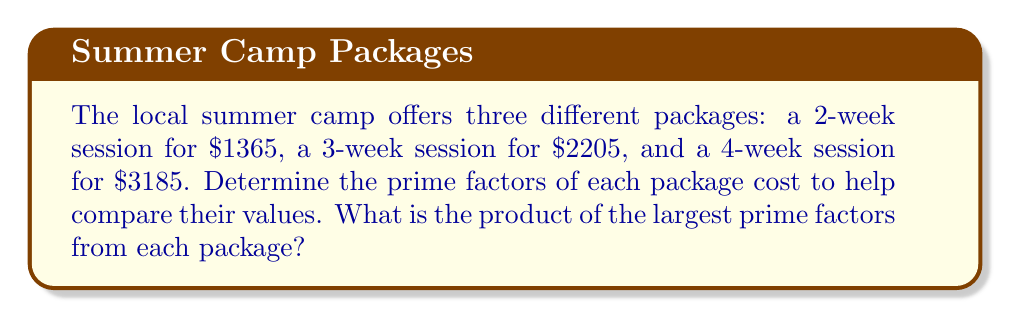Can you solve this math problem? Let's find the prime factors of each package cost:

1. 2-week session: $1365
   $1365 = 3 \times 5 \times 7 \times 13$

2. 3-week session: $2205
   $2205 = 3^2 \times 5 \times 7^2$

3. 4-week session: $3185
   $3185 = 5 \times 637$

Now, we identify the largest prime factor for each package:
1. 2-week session: 13
2. 3-week session: 7
3. 4-week session: 637

To find the product of these largest prime factors:

$13 \times 7 \times 637 = 58,006$

This calculation helps compare the relative "value" of each package by considering their largest prime components.
Answer: $58,006$ 